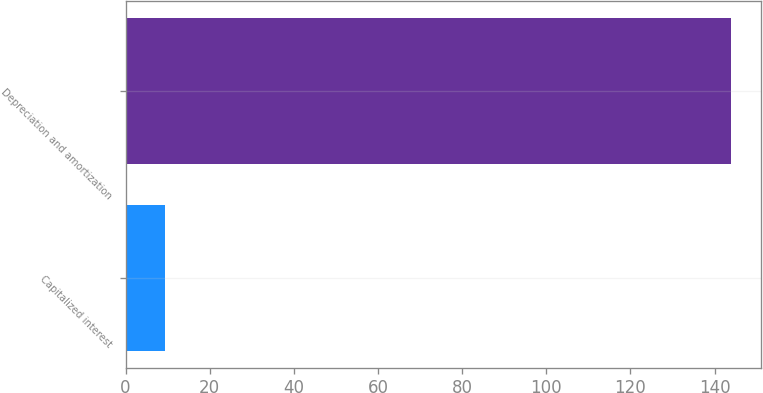Convert chart. <chart><loc_0><loc_0><loc_500><loc_500><bar_chart><fcel>Capitalized interest<fcel>Depreciation and amortization<nl><fcel>9.3<fcel>143.9<nl></chart> 